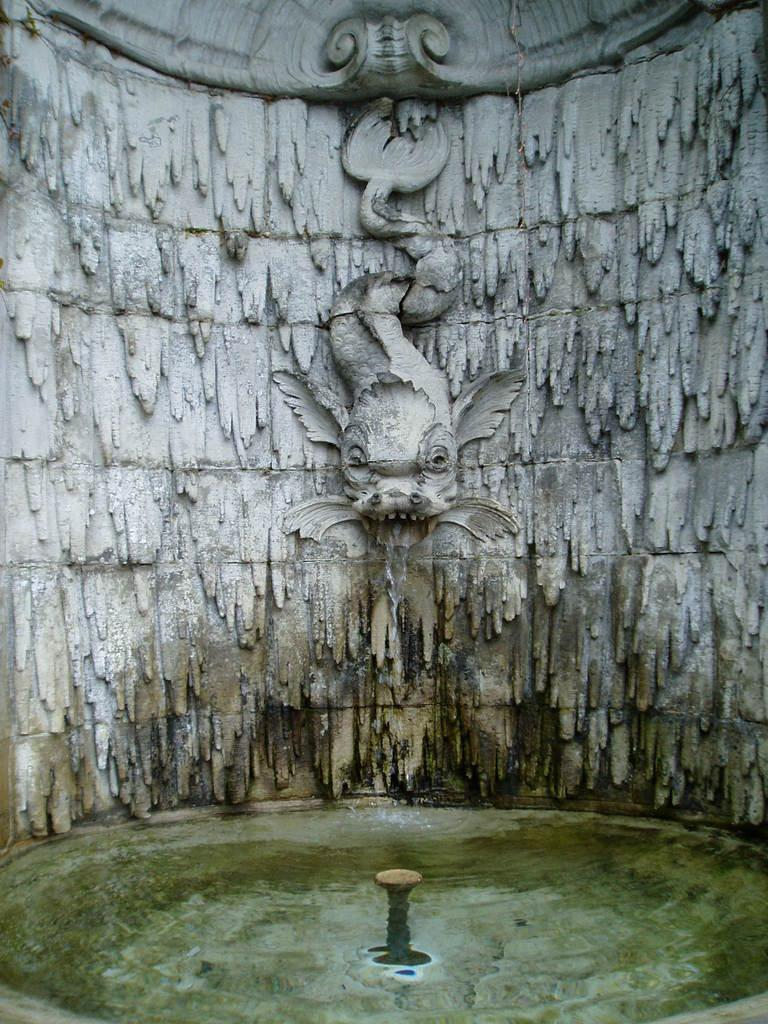What type of statue is on the wall in the image? There is a statue of a dragon on the wall in the image. What can be seen at the bottom of the image? There is a fountain at the bottom of the image. What is the liquid substance visible in the image? Water is visible in the image. Where is the nest of the dragon in the image? There is no nest present in the image, as it features a statue of a dragon and not a real dragon. How does the statue help the dragon in the image? The statue does not help the dragon, as it is a non-living object and not a real dragon. 